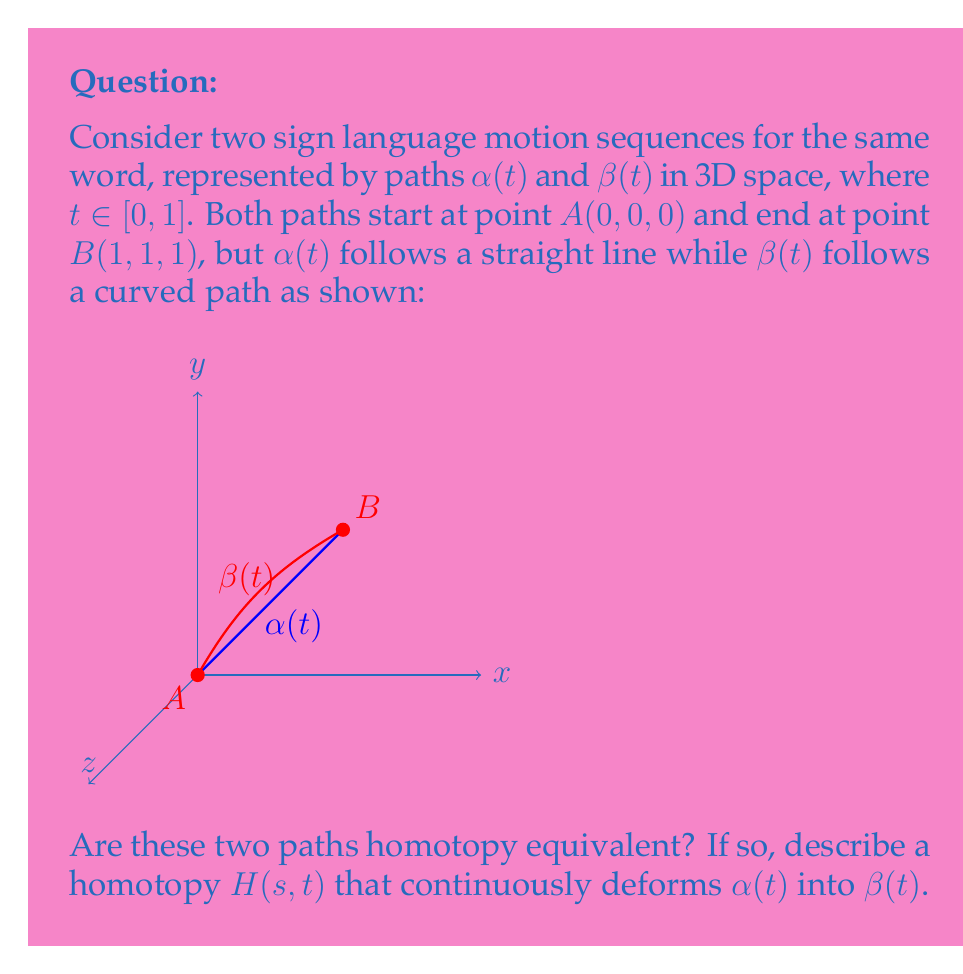Show me your answer to this math problem. To determine if the paths $\alpha(t)$ and $\beta(t)$ are homotopy equivalent, we need to find a continuous function $H(s,t)$ that deforms one path into the other. Let's approach this step-by-step:

1) First, we need to define our paths mathematically:
   $\alpha(t) = (t, t, t)$ for $t \in [0,1]$ (straight line)
   $\beta(t)$ is a continuous curve from $(0,0,0)$ to $(1,1,1)$

2) A homotopy between these paths would be a continuous function $H: [0,1] \times [0,1] \rightarrow \mathbb{R}^3$ such that:
   $H(0,t) = \alpha(t)$
   $H(1,t) = \beta(t)$
   $H(s,0) = (0,0,0)$ and $H(s,1) = (1,1,1)$ for all $s \in [0,1]$

3) We can define such a homotopy as:
   $H(s,t) = (1-s)\alpha(t) + s\beta(t)$

4) Let's verify that this $H(s,t)$ satisfies our conditions:
   - When $s=0$, $H(0,t) = \alpha(t)$
   - When $s=1$, $H(1,t) = \beta(t)$
   - For all $s$, $H(s,0) = (1-s)(0,0,0) + s(0,0,0) = (0,0,0)$
   - For all $s$, $H(s,1) = (1-s)(1,1,1) + s(1,1,1) = (1,1,1)$

5) This homotopy continuously deforms $\alpha(t)$ into $\beta(t)$ as $s$ varies from 0 to 1.

6) The existence of this homotopy proves that $\alpha(t)$ and $\beta(t)$ are homotopy equivalent.

In the context of sign language motion sequences, this homotopy equivalence suggests that these two motion paths can be continuously transformed into each other without breaking the path. This could be useful in analyzing and comparing different signing styles or variations in sign execution.
Answer: Yes, $H(s,t) = (1-s)\alpha(t) + s\beta(t)$ 